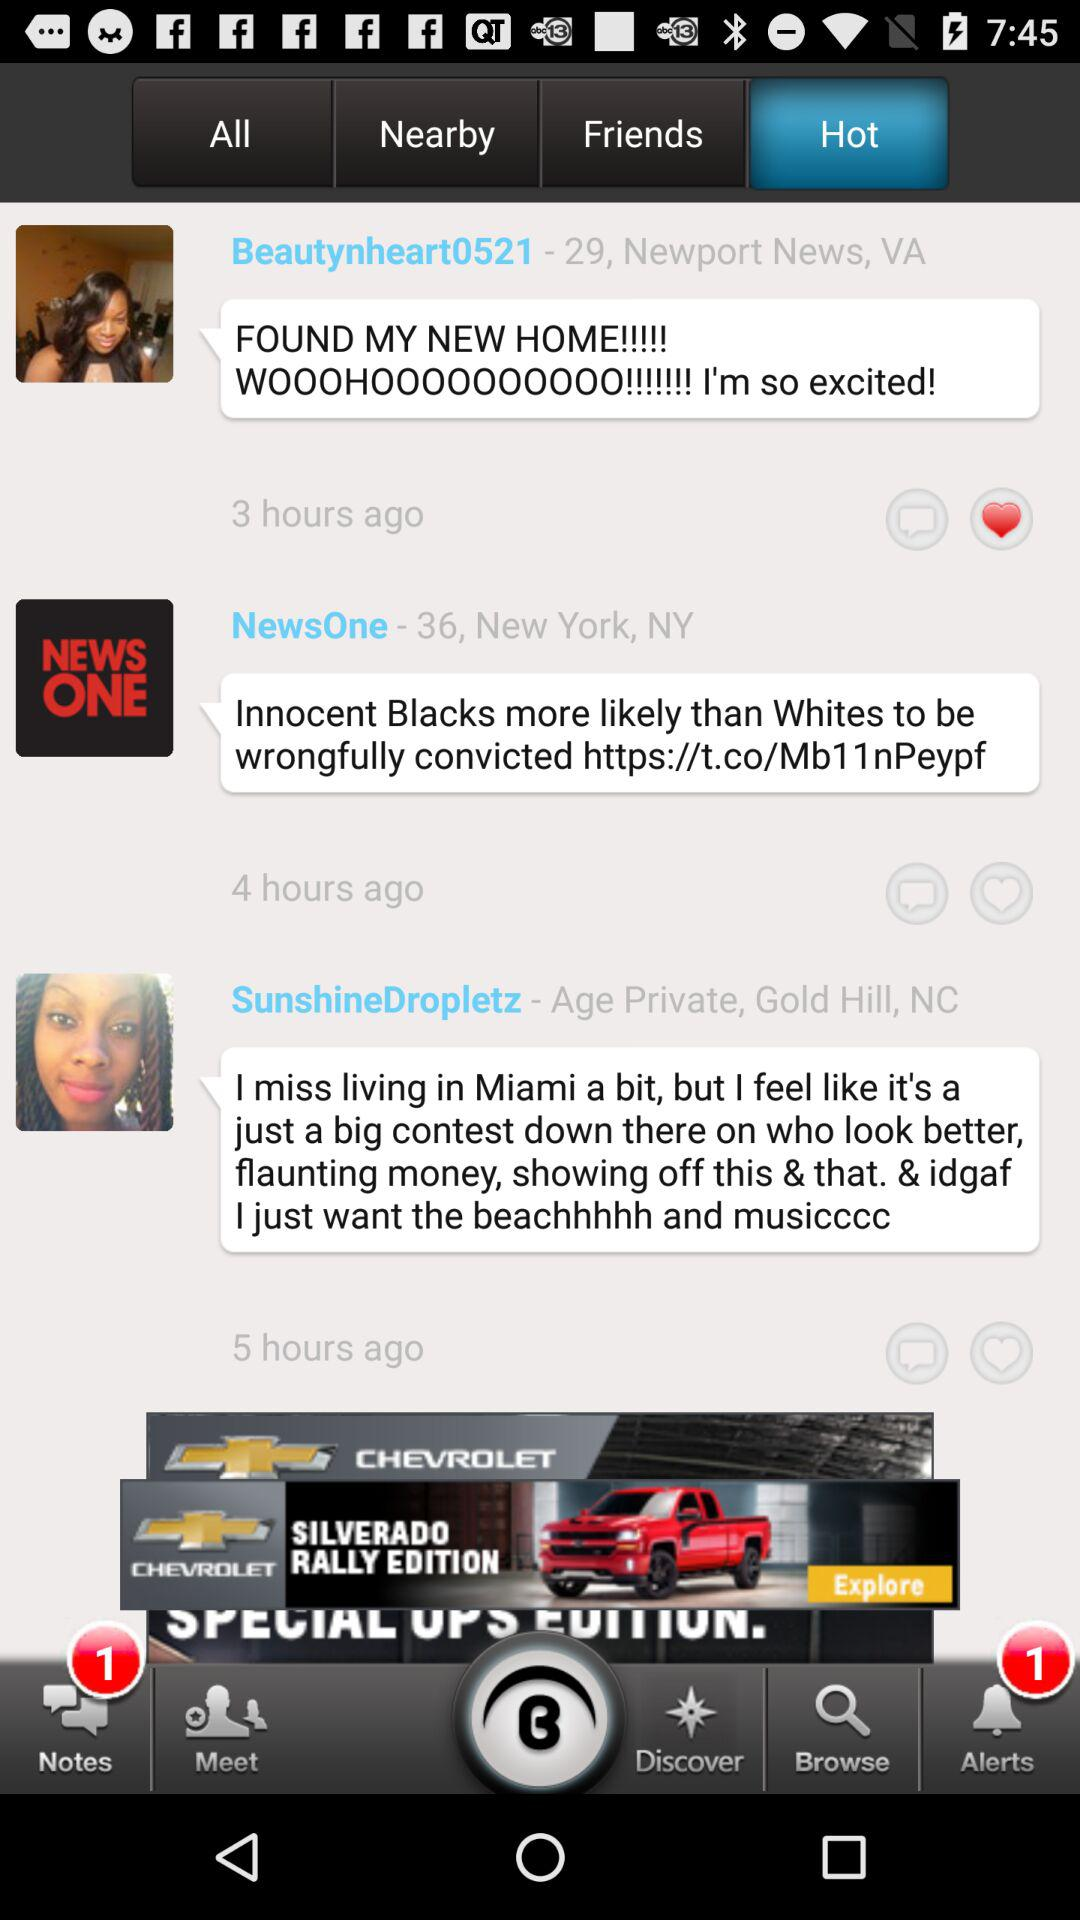How many alerts were there? There was 1 alert. 